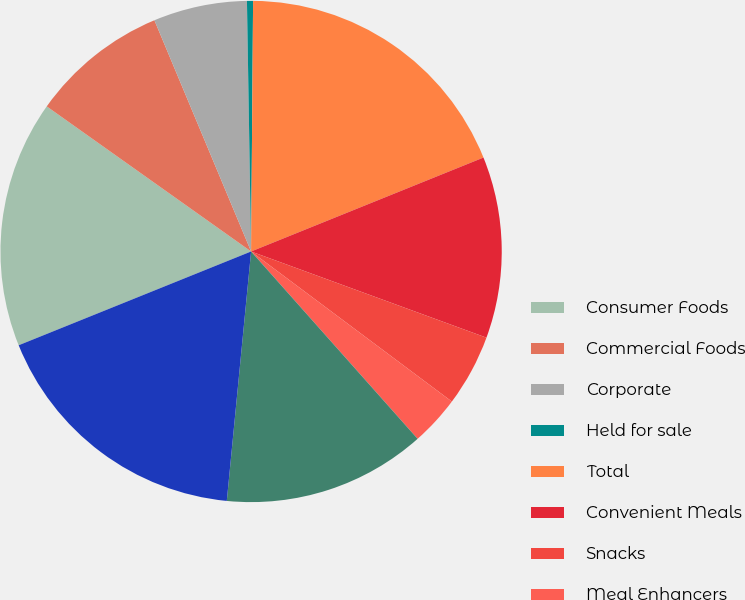Convert chart. <chart><loc_0><loc_0><loc_500><loc_500><pie_chart><fcel>Consumer Foods<fcel>Commercial Foods<fcel>Corporate<fcel>Held for sale<fcel>Total<fcel>Convenient Meals<fcel>Snacks<fcel>Meal Enhancers<fcel>Specialty Foods<fcel>Total Consumer Foods<nl><fcel>15.93%<fcel>8.87%<fcel>6.04%<fcel>0.39%<fcel>18.76%<fcel>11.7%<fcel>4.63%<fcel>3.22%<fcel>13.11%<fcel>17.35%<nl></chart> 